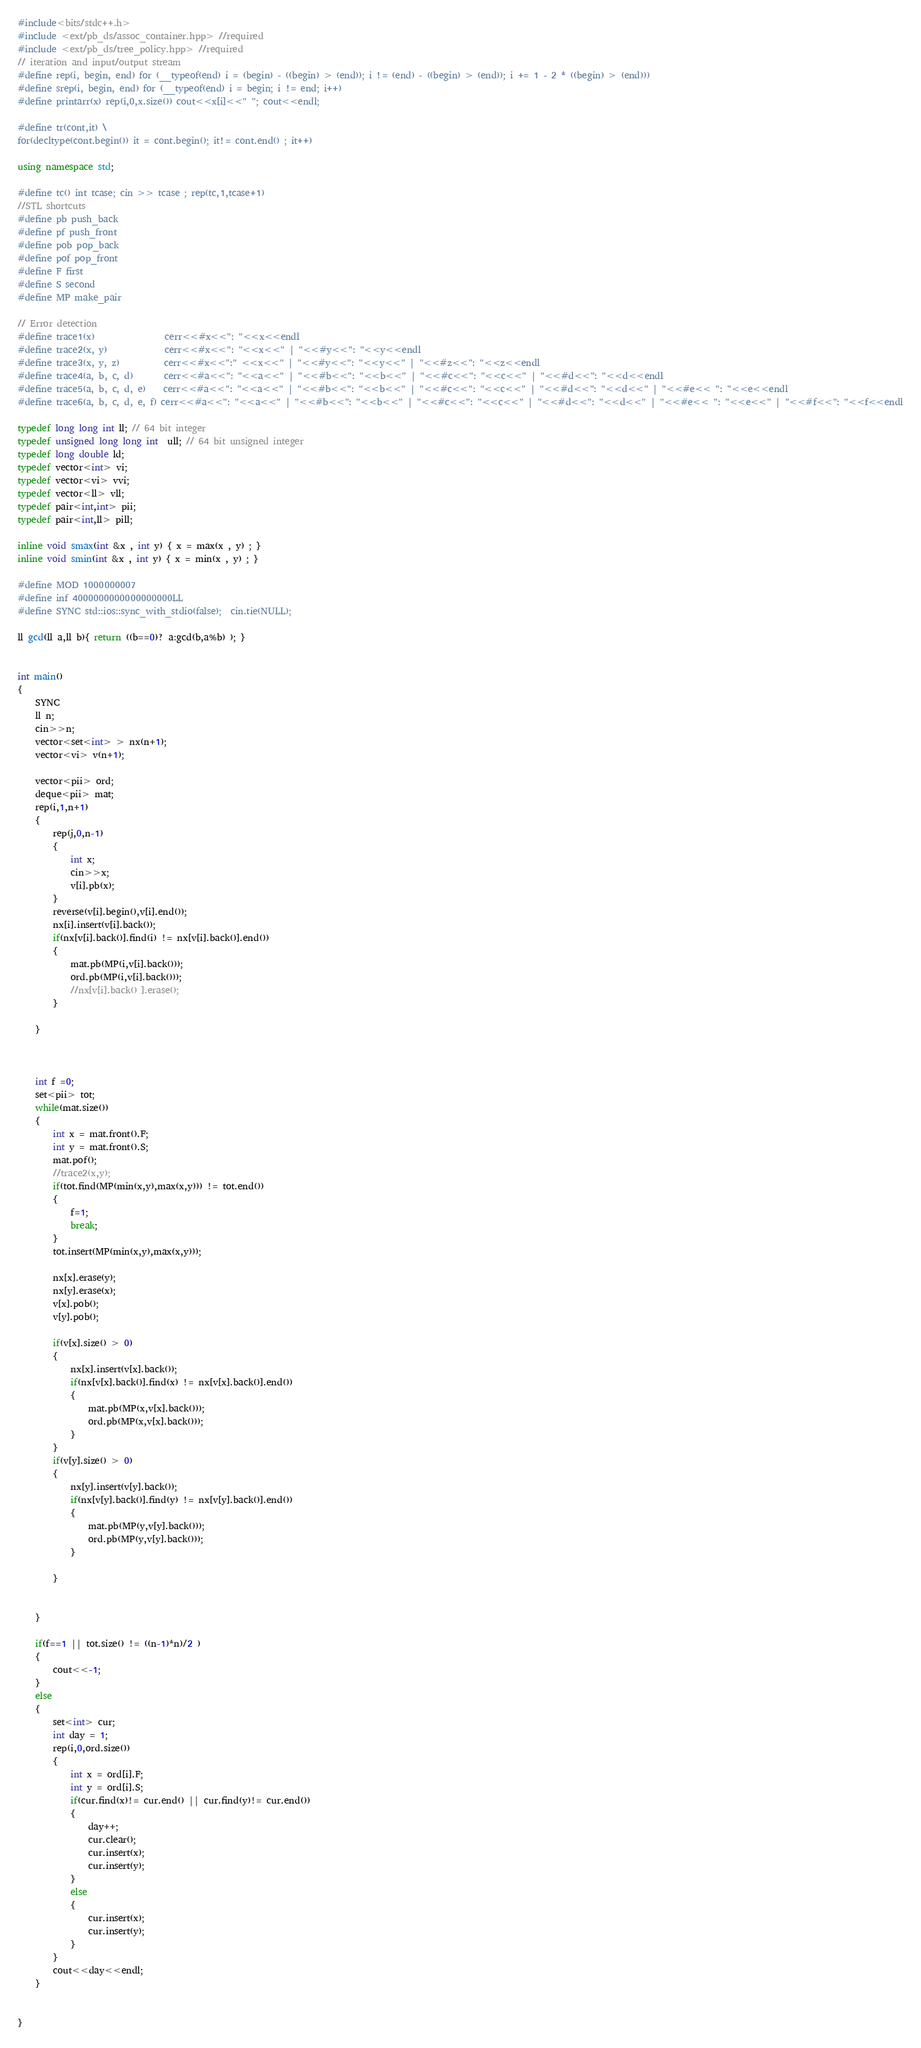<code> <loc_0><loc_0><loc_500><loc_500><_C++_>#include<bits/stdc++.h>
#include <ext/pb_ds/assoc_container.hpp> //required
#include <ext/pb_ds/tree_policy.hpp> //required
// iteration and input/output stream
#define rep(i, begin, end) for (__typeof(end) i = (begin) - ((begin) > (end)); i != (end) - ((begin) > (end)); i += 1 - 2 * ((begin) > (end)))
#define srep(i, begin, end) for (__typeof(end) i = begin; i != end; i++)
#define printarr(x) rep(i,0,x.size()) cout<<x[i]<<" "; cout<<endl;

#define tr(cont,it) \
for(decltype(cont.begin()) it = cont.begin(); it!= cont.end() ; it++)

using namespace std;

#define tc() int tcase; cin >> tcase ; rep(tc,1,tcase+1)
//STL shortcuts
#define pb push_back
#define pf push_front
#define pob pop_back
#define pof pop_front
#define F first
#define S second
#define MP make_pair

// Error detection
#define trace1(x)                cerr<<#x<<": "<<x<<endl
#define trace2(x, y)             cerr<<#x<<": "<<x<<" | "<<#y<<": "<<y<<endl
#define trace3(x, y, z)          cerr<<#x<<":" <<x<<" | "<<#y<<": "<<y<<" | "<<#z<<": "<<z<<endl
#define trace4(a, b, c, d)       cerr<<#a<<": "<<a<<" | "<<#b<<": "<<b<<" | "<<#c<<": "<<c<<" | "<<#d<<": "<<d<<endl
#define trace5(a, b, c, d, e)    cerr<<#a<<": "<<a<<" | "<<#b<<": "<<b<<" | "<<#c<<": "<<c<<" | "<<#d<<": "<<d<<" | "<<#e<< ": "<<e<<endl
#define trace6(a, b, c, d, e, f) cerr<<#a<<": "<<a<<" | "<<#b<<": "<<b<<" | "<<#c<<": "<<c<<" | "<<#d<<": "<<d<<" | "<<#e<< ": "<<e<<" | "<<#f<<": "<<f<<endl

typedef long long int ll; // 64 bit integer
typedef unsigned long long int  ull; // 64 bit unsigned integer
typedef long double ld;
typedef vector<int> vi;
typedef vector<vi> vvi;
typedef vector<ll> vll;
typedef pair<int,int> pii;
typedef pair<int,ll> pill;

inline void smax(int &x , int y) { x = max(x , y) ; }
inline void smin(int &x , int y) { x = min(x , y) ; }

#define MOD 1000000007
#define inf 4000000000000000000LL
#define SYNC std::ios::sync_with_stdio(false);  cin.tie(NULL);

ll gcd(ll a,ll b){ return ((b==0)? a:gcd(b,a%b) ); }


int main()
{
    SYNC
    ll n;
    cin>>n;
    vector<set<int> > nx(n+1);
    vector<vi> v(n+1);

    vector<pii> ord;
    deque<pii> mat;
    rep(i,1,n+1)
    {
        rep(j,0,n-1)
        {
            int x;
            cin>>x;
            v[i].pb(x);
        }
        reverse(v[i].begin(),v[i].end());
        nx[i].insert(v[i].back());
        if(nx[v[i].back()].find(i) != nx[v[i].back()].end())
        {
            mat.pb(MP(i,v[i].back()));
            ord.pb(MP(i,v[i].back()));
            //nx[v[i].back() ].erase();
        }

    }



    int f =0;
    set<pii> tot;
    while(mat.size())
    {
        int x = mat.front().F;
        int y = mat.front().S;
        mat.pof();
        //trace2(x,y);
        if(tot.find(MP(min(x,y),max(x,y))) != tot.end())
        {
            f=1;
            break;
        }
        tot.insert(MP(min(x,y),max(x,y)));

        nx[x].erase(y);
        nx[y].erase(x);
        v[x].pob();
        v[y].pob();

        if(v[x].size() > 0)
        {
            nx[x].insert(v[x].back());
            if(nx[v[x].back()].find(x) != nx[v[x].back()].end())
            {
                mat.pb(MP(x,v[x].back()));
                ord.pb(MP(x,v[x].back()));
            }
        }
        if(v[y].size() > 0)
        {
            nx[y].insert(v[y].back());
            if(nx[v[y].back()].find(y) != nx[v[y].back()].end())
            {
                mat.pb(MP(y,v[y].back()));
                ord.pb(MP(y,v[y].back()));
            }

        }


    }

    if(f==1 || tot.size() != ((n-1)*n)/2 )
    {
        cout<<-1;
    }
    else
    {
        set<int> cur;
        int day = 1;
        rep(i,0,ord.size())
        {
            int x = ord[i].F;
            int y = ord[i].S;
            if(cur.find(x)!= cur.end() || cur.find(y)!= cur.end())
            {
                day++;
                cur.clear();
                cur.insert(x);
                cur.insert(y);
            }
            else
            {
                cur.insert(x);
                cur.insert(y);
            }
        }
        cout<<day<<endl;
    }


}
</code> 